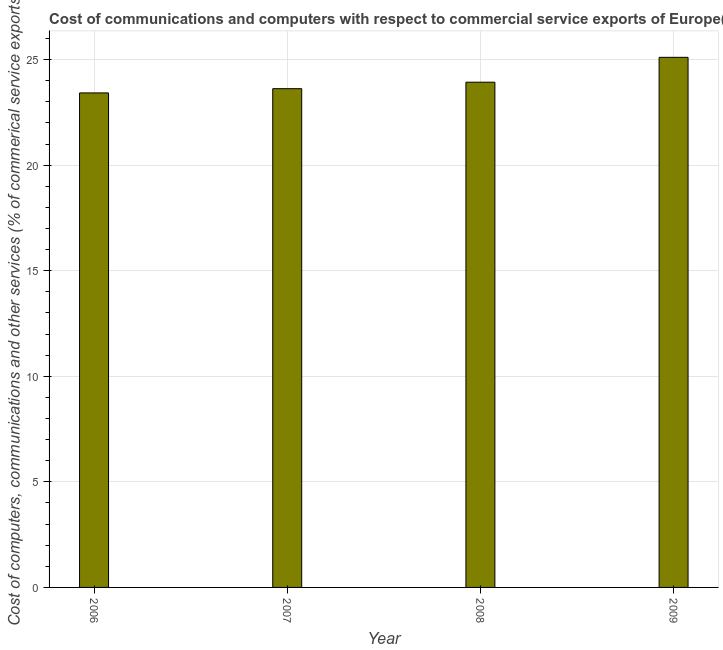What is the title of the graph?
Ensure brevity in your answer.  Cost of communications and computers with respect to commercial service exports of Europe(developing only). What is the label or title of the Y-axis?
Offer a very short reply. Cost of computers, communications and other services (% of commerical service exports). What is the cost of communications in 2008?
Offer a terse response. 23.93. Across all years, what is the maximum cost of communications?
Ensure brevity in your answer.  25.11. Across all years, what is the minimum  computer and other services?
Offer a very short reply. 23.42. In which year was the cost of communications maximum?
Make the answer very short. 2009. In which year was the  computer and other services minimum?
Make the answer very short. 2006. What is the sum of the  computer and other services?
Offer a terse response. 96.07. What is the difference between the cost of communications in 2006 and 2007?
Offer a terse response. -0.2. What is the average  computer and other services per year?
Your response must be concise. 24.02. What is the median  computer and other services?
Your answer should be very brief. 23.77. In how many years, is the cost of communications greater than 8 %?
Ensure brevity in your answer.  4. Do a majority of the years between 2006 and 2007 (inclusive) have  computer and other services greater than 12 %?
Offer a very short reply. Yes. Is the  computer and other services in 2006 less than that in 2008?
Your answer should be very brief. Yes. Is the difference between the  computer and other services in 2006 and 2009 greater than the difference between any two years?
Offer a very short reply. Yes. What is the difference between the highest and the second highest cost of communications?
Provide a short and direct response. 1.18. What is the difference between the highest and the lowest cost of communications?
Offer a terse response. 1.69. How many bars are there?
Keep it short and to the point. 4. How many years are there in the graph?
Your answer should be compact. 4. What is the difference between two consecutive major ticks on the Y-axis?
Provide a short and direct response. 5. What is the Cost of computers, communications and other services (% of commerical service exports) in 2006?
Your answer should be very brief. 23.42. What is the Cost of computers, communications and other services (% of commerical service exports) in 2007?
Your answer should be very brief. 23.62. What is the Cost of computers, communications and other services (% of commerical service exports) in 2008?
Give a very brief answer. 23.93. What is the Cost of computers, communications and other services (% of commerical service exports) of 2009?
Offer a terse response. 25.11. What is the difference between the Cost of computers, communications and other services (% of commerical service exports) in 2006 and 2007?
Offer a very short reply. -0.2. What is the difference between the Cost of computers, communications and other services (% of commerical service exports) in 2006 and 2008?
Your answer should be compact. -0.51. What is the difference between the Cost of computers, communications and other services (% of commerical service exports) in 2006 and 2009?
Provide a succinct answer. -1.69. What is the difference between the Cost of computers, communications and other services (% of commerical service exports) in 2007 and 2008?
Offer a terse response. -0.31. What is the difference between the Cost of computers, communications and other services (% of commerical service exports) in 2007 and 2009?
Your answer should be compact. -1.49. What is the difference between the Cost of computers, communications and other services (% of commerical service exports) in 2008 and 2009?
Give a very brief answer. -1.18. What is the ratio of the Cost of computers, communications and other services (% of commerical service exports) in 2006 to that in 2007?
Your response must be concise. 0.99. What is the ratio of the Cost of computers, communications and other services (% of commerical service exports) in 2006 to that in 2009?
Ensure brevity in your answer.  0.93. What is the ratio of the Cost of computers, communications and other services (% of commerical service exports) in 2007 to that in 2009?
Your answer should be compact. 0.94. What is the ratio of the Cost of computers, communications and other services (% of commerical service exports) in 2008 to that in 2009?
Ensure brevity in your answer.  0.95. 